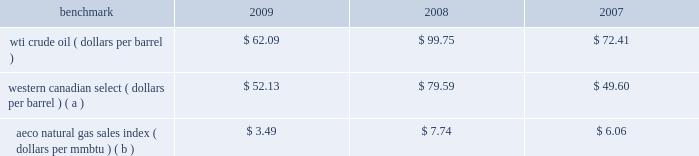Natural gas prices on average were lower in 2009 than in 2008 and in 2007 , with prices in 2008 hitting uniquely high levels .
A significant portion of our natural gas production in the lower 48 states of the u.s .
Is sold at bid-week prices or first-of-month indices relative to our specific producing areas .
A large portion of natural gas sales in alaska are subject to term contracts .
Our other major natural gas-producing regions are europe and equatorial guinea , where large portions of our natural gas sales are also subject to term contracts , making realized prices in these areas less volatile .
As we sell larger quantities of natural gas from these regions , to the extent that these fixed prices are lower than prevailing prices , our reported average natural gas prices realizations may be less than benchmark natural gas prices .
Oil sands mining oil sands mining segment revenues correlate with prevailing market prices for the various qualities of synthetic crude oil and vacuum gas oil we produce .
Roughly two-thirds of the normal output mix will track movements in wti and one-third will track movements in the canadian heavy sour crude oil marker , primarily western canadian select .
Output mix can be impacted by operational problems or planned unit outages at the mine or the upgrader .
The operating cost structure of the oil sands mining operations is predominantly fixed and therefore many of the costs incurred in times of full operation continue during production downtime .
Per-unit costs are sensitive to production rates .
Key variable costs are natural gas and diesel fuel , which track commodity markets such as the canadian aeco natural gas sales index and crude prices respectively .
The table below shows average benchmark prices that impact both our revenues and variable costs. .
Western canadian select ( dollars per barrel ) ( a ) $ 52.13 $ 79.59 $ 49.60 aeco natural gas sales index ( dollars per mmbtu ) ( b ) $ 3.49 $ 7.74 $ 6.06 ( a ) monthly pricing based upon average wti adjusted for differentials unique to western canada .
( b ) alberta energy company day ahead index .
Integrated gas our integrated gas strategy is to link stranded natural gas resources with areas where a supply gap is emerging due to declining production and growing demand .
Our integrated gas operations include marketing and transportation of products manufactured from natural gas , such as lng and methanol , primarily in west africa , the u.s .
And europe .
Our most significant lng investment is our 60 percent ownership in a production facility in equatorial guinea , which sells lng under a long-term contract at prices tied to henry hub natural gas prices .
In 2009 , the gross sales from the plant were 3.9 million metric tonnes , while in 2008 , its first full year of operations , the plant sold 3.4 million metric tonnes .
Industry estimates of 2009 lng trade are approximately 185 million metric tonnes .
More lng production facilities and tankers were under construction in 2009 .
As a result of the sharp worldwide economic downturn in 2008 , continued weak economies are expected to lower natural gas consumption in various countries ; therefore , affecting near-term demand for lng .
Long-term lng supply continues to be in demand as markets seek the benefits of clean burning natural gas .
Market prices for lng are not reported or posted .
In general , lng delivered to the u.s .
Is tied to henry hub prices and will track with changes in u.s .
Natural gas prices , while lng sold in europe and asia is indexed to crude oil prices and will track the movement of those prices .
We own a 45 percent interest in a methanol plant located in equatorial guinea through our investment in ampco .
Gross sales of methanol from the plant totaled 960374 metric tonnes in 2009 and 792794 metric tonnes in 2008 .
Methanol demand has a direct impact on ampco 2019s earnings .
Because global demand for methanol is rather limited , changes in the supply-demand balance can have a significant impact on sales prices .
The 2010 chemical markets associates , inc .
Estimates world demand for methanol in 2009 was 41 million metric tonnes .
Our plant capacity is 1.1 million , or about 3 percent of total demand .
Refining , marketing and transportation rm&t segment income depends largely on our refining and wholesale marketing gross margin , refinery throughputs and retail marketing gross margins for gasoline , distillates and merchandise. .
What was the difference in the average price of wti crude oil and western canadian select during 2008?? 
Computations: (99.75 - 79.59)
Answer: 20.16. 